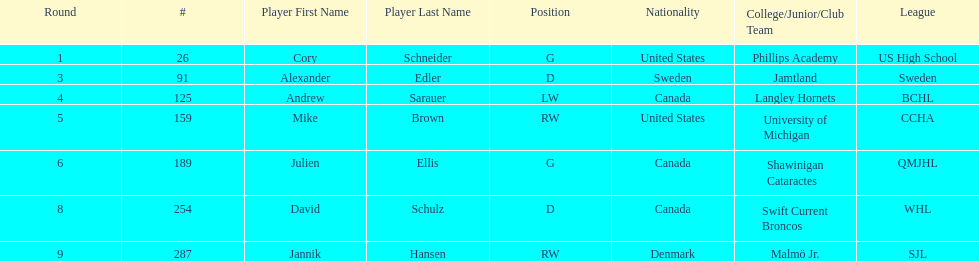I'm looking to parse the entire table for insights. Could you assist me with that? {'header': ['Round', '#', 'Player First Name', 'Player Last Name', 'Position', 'Nationality', 'College/Junior/Club Team', 'League'], 'rows': [['1', '26', 'Cory', 'Schneider', 'G', 'United States', 'Phillips Academy', 'US High School'], ['3', '91', 'Alexander', 'Edler', 'D', 'Sweden', 'Jamtland', 'Sweden'], ['4', '125', 'Andrew', 'Sarauer', 'LW', 'Canada', 'Langley Hornets', 'BCHL'], ['5', '159', 'Mike', 'Brown', 'RW', 'United States', 'University of Michigan', 'CCHA'], ['6', '189', 'Julien', 'Ellis', 'G', 'Canada', 'Shawinigan Cataractes', 'QMJHL'], ['8', '254', 'David', 'Schulz', 'D', 'Canada', 'Swift Current Broncos', 'WHL'], ['9', '287', 'Jannik', 'Hansen', 'RW', 'Denmark', 'Malmö Jr.', 'SJL']]} The first round not to have a draft pick. 2. 